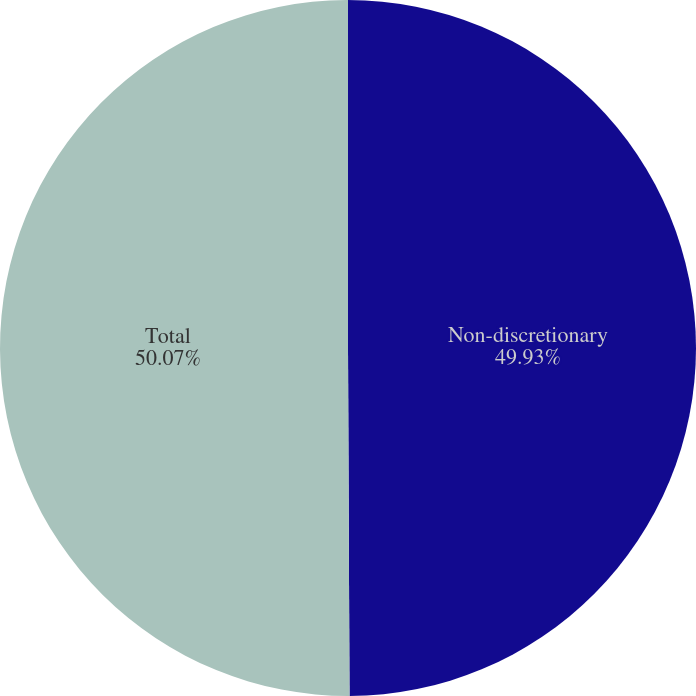Convert chart. <chart><loc_0><loc_0><loc_500><loc_500><pie_chart><fcel>Non-discretionary<fcel>Total<nl><fcel>49.93%<fcel>50.07%<nl></chart> 